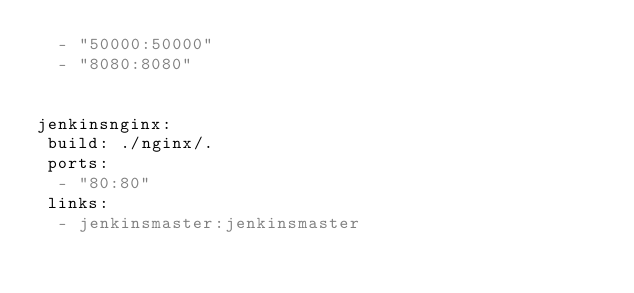<code> <loc_0><loc_0><loc_500><loc_500><_YAML_>  - "50000:50000"
  - "8080:8080"


jenkinsnginx:
 build: ./nginx/.
 ports:
  - "80:80"
 links:
  - jenkinsmaster:jenkinsmaster
</code> 